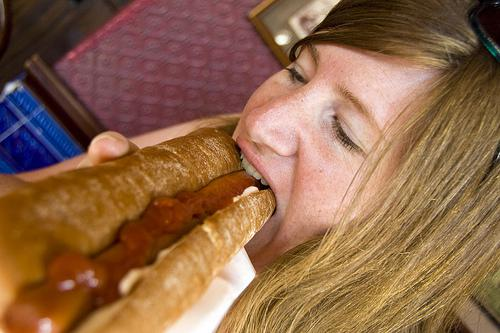Question: what is on the dog?
Choices:
A. Collar.
B. Cute sweater.
C. Mud.
D. Some sauce.
Answer with the letter. Answer: D Question: why is her mouth wide?
Choices:
A. She is yelling at the sandwich.
B. She s visiting the dentist.
C. She is an opera singer.
D. The sandwich is huge.
Answer with the letter. Answer: D Question: where is this scene?
Choices:
A. At a doctor's office.
B. In a movie theater.
C. At a sandwich shop.
D. At school.
Answer with the letter. Answer: C Question: what is the sandwich?
Choices:
A. Peanut butter and jelly.
B. Tuna salad on wheat.
C. A sausage on a bun.
D. Grilled cheese.
Answer with the letter. Answer: C Question: how long is it?
Choices:
A. 3 inches.
B. A foot long at least.
C. 4 feet.
D. 2 meters.
Answer with the letter. Answer: B Question: when will she finish?
Choices:
A. In 30 seconds.
B. She may not.
C. In 2 days.
D. In 4 weeks.
Answer with the letter. Answer: B Question: who prepared the sandwich?
Choices:
A. A cook.
B. Mother.
C. A restaurant employee.
D. A man in blue jeans.
Answer with the letter. Answer: A Question: what color is her hair?
Choices:
A. Red.
B. Blonde.
C. Black.
D. Brown.
Answer with the letter. Answer: B 